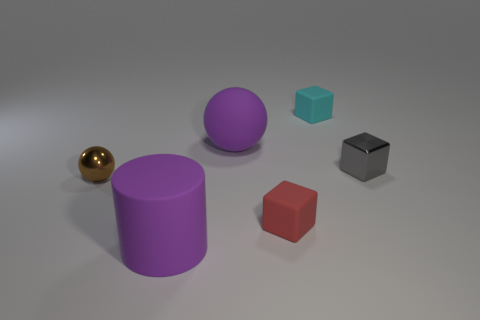What are the different shapes visible in the image and what colors are they? In the image, there are several shaped objects in a variety of colors. There is a round, shiny gold sphere; a tall purple cylinder; a lavender sphere; a small teal cube; and a small red cube. 